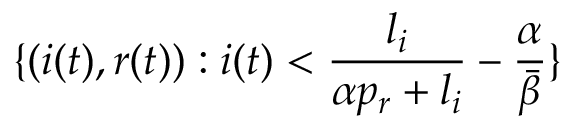<formula> <loc_0><loc_0><loc_500><loc_500>\{ ( i ( t ) , r ( t ) ) \colon i ( t ) < \frac { l _ { i } } { \alpha p _ { r } + l _ { i } } - \frac { \alpha } { \bar { \beta } } \}</formula> 